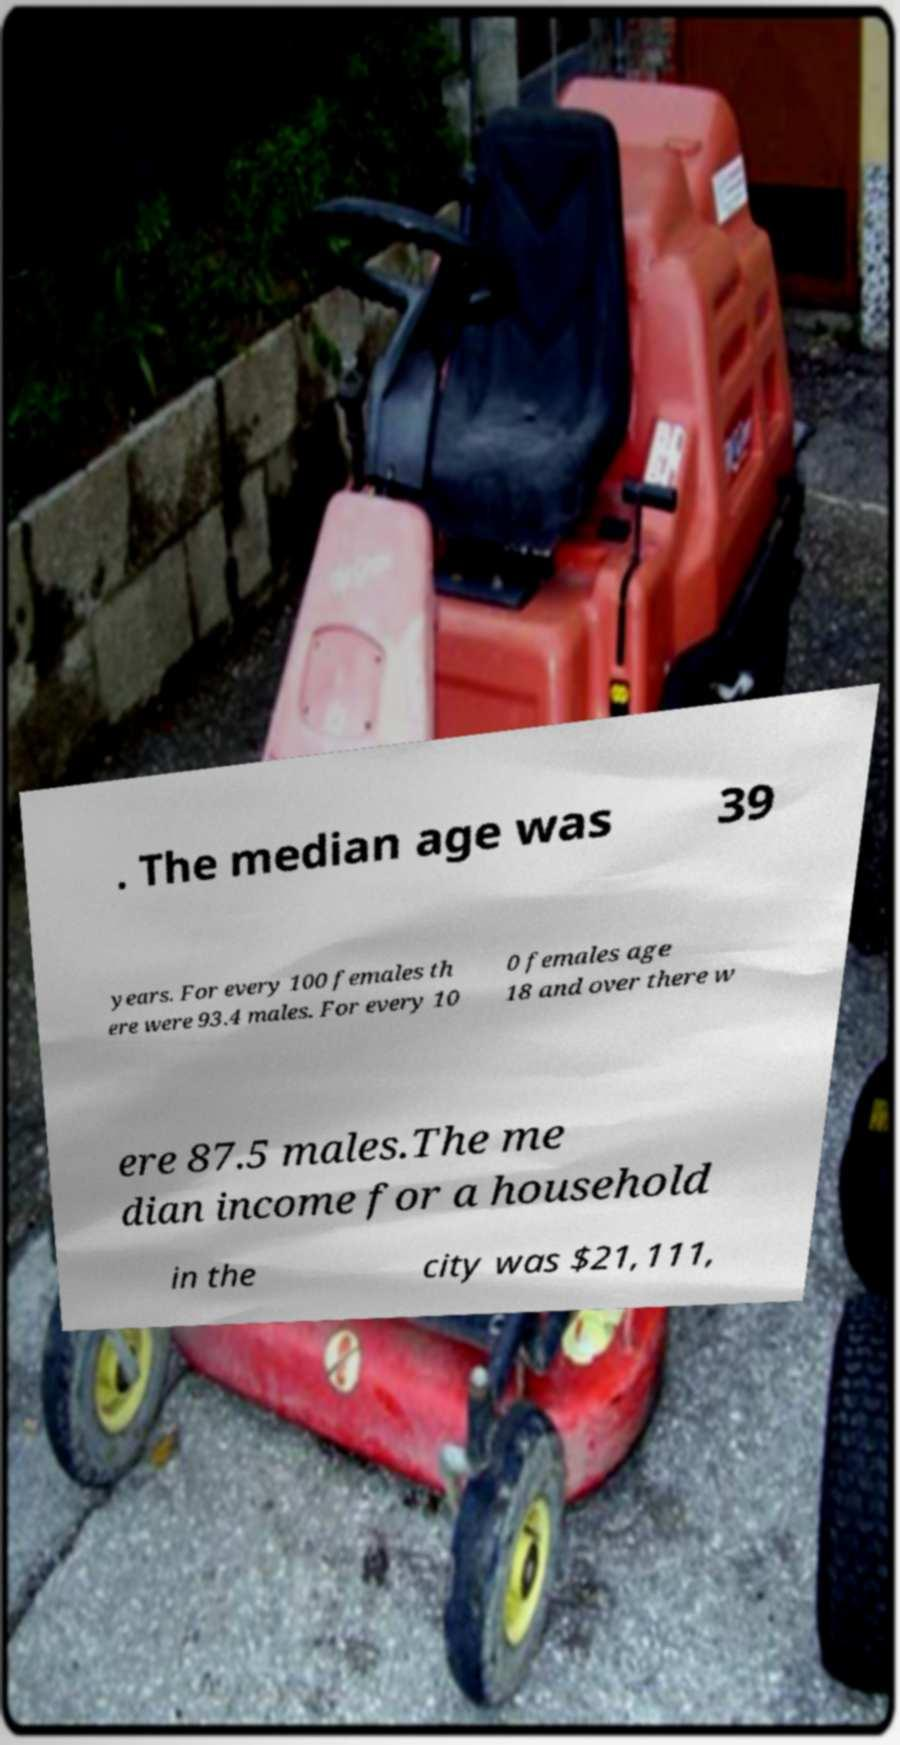Please identify and transcribe the text found in this image. . The median age was 39 years. For every 100 females th ere were 93.4 males. For every 10 0 females age 18 and over there w ere 87.5 males.The me dian income for a household in the city was $21,111, 